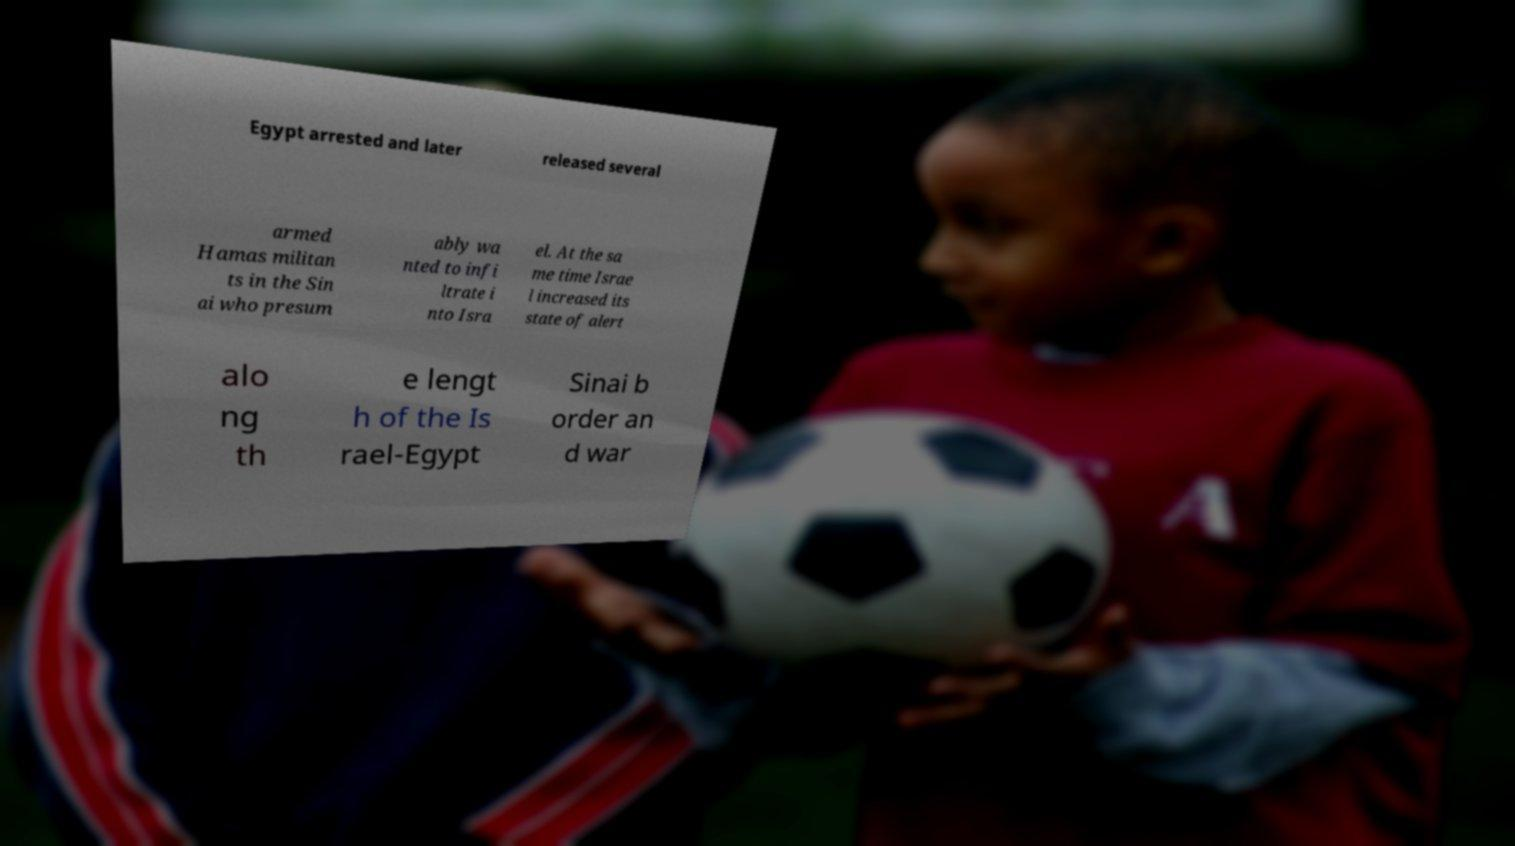Could you extract and type out the text from this image? Egypt arrested and later released several armed Hamas militan ts in the Sin ai who presum ably wa nted to infi ltrate i nto Isra el. At the sa me time Israe l increased its state of alert alo ng th e lengt h of the Is rael-Egypt Sinai b order an d war 